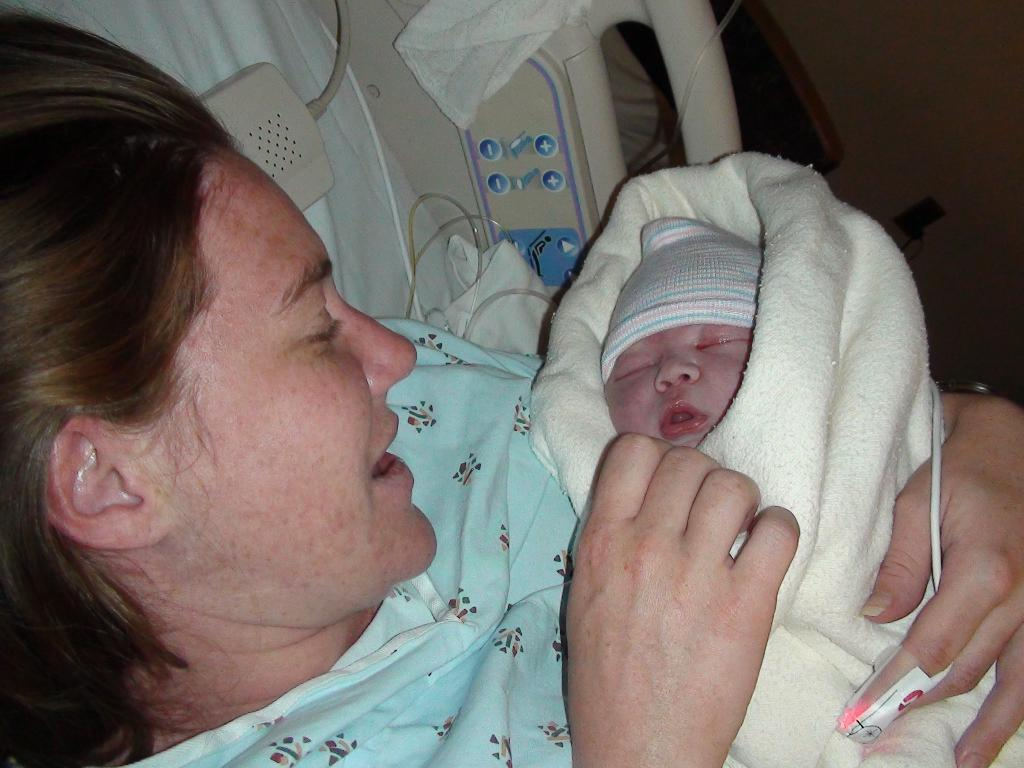What is the person in the image holding? The person is holding a baby in the image. How is the baby dressed or covered? The baby is wrapped in a cloth. What can be seen in the background of the image? There is a curtain visible in the image. What else can be seen in the image besides the baby and the person holding it? There is a cloth visible in the image, as well as a few objects. What is on the right side of the image? There is a wall on the right side of the image. What time of day is it in the image, and how does the person adjust their knee to accommodate the baby? The time of day is not mentioned in the image, and there is no indication of the person adjusting their knee to accommodate the baby. 